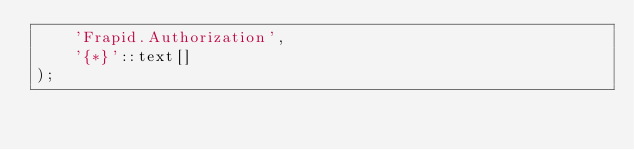Convert code to text. <code><loc_0><loc_0><loc_500><loc_500><_SQL_>    'Frapid.Authorization',
    '{*}'::text[]
);
</code> 